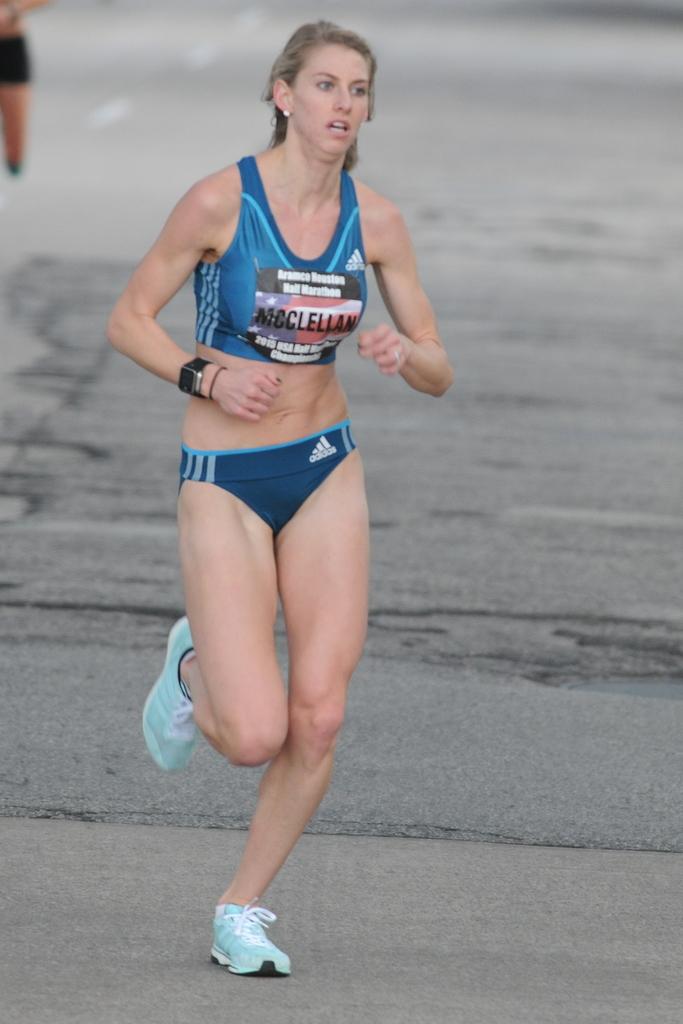What is this person's name?
Make the answer very short. Mcclellan. What is the name of the brand that made her underwears?
Provide a succinct answer. Adidas. 